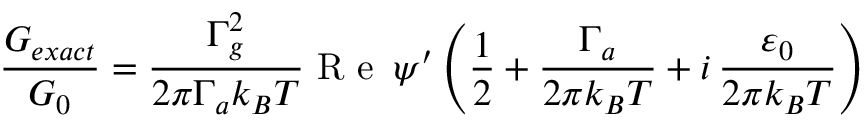Convert formula to latex. <formula><loc_0><loc_0><loc_500><loc_500>\frac { G _ { e x a c t } } { G _ { 0 } } = \frac { \Gamma _ { g } ^ { 2 } } { 2 \pi \Gamma _ { a } k _ { B } T } R e \, \psi ^ { \prime } \left ( \frac { 1 } { 2 } + \frac { \Gamma _ { a } } { 2 \pi k _ { B } T } + i \, \frac { \varepsilon _ { 0 } } { 2 \pi k _ { B } T } \right )</formula> 